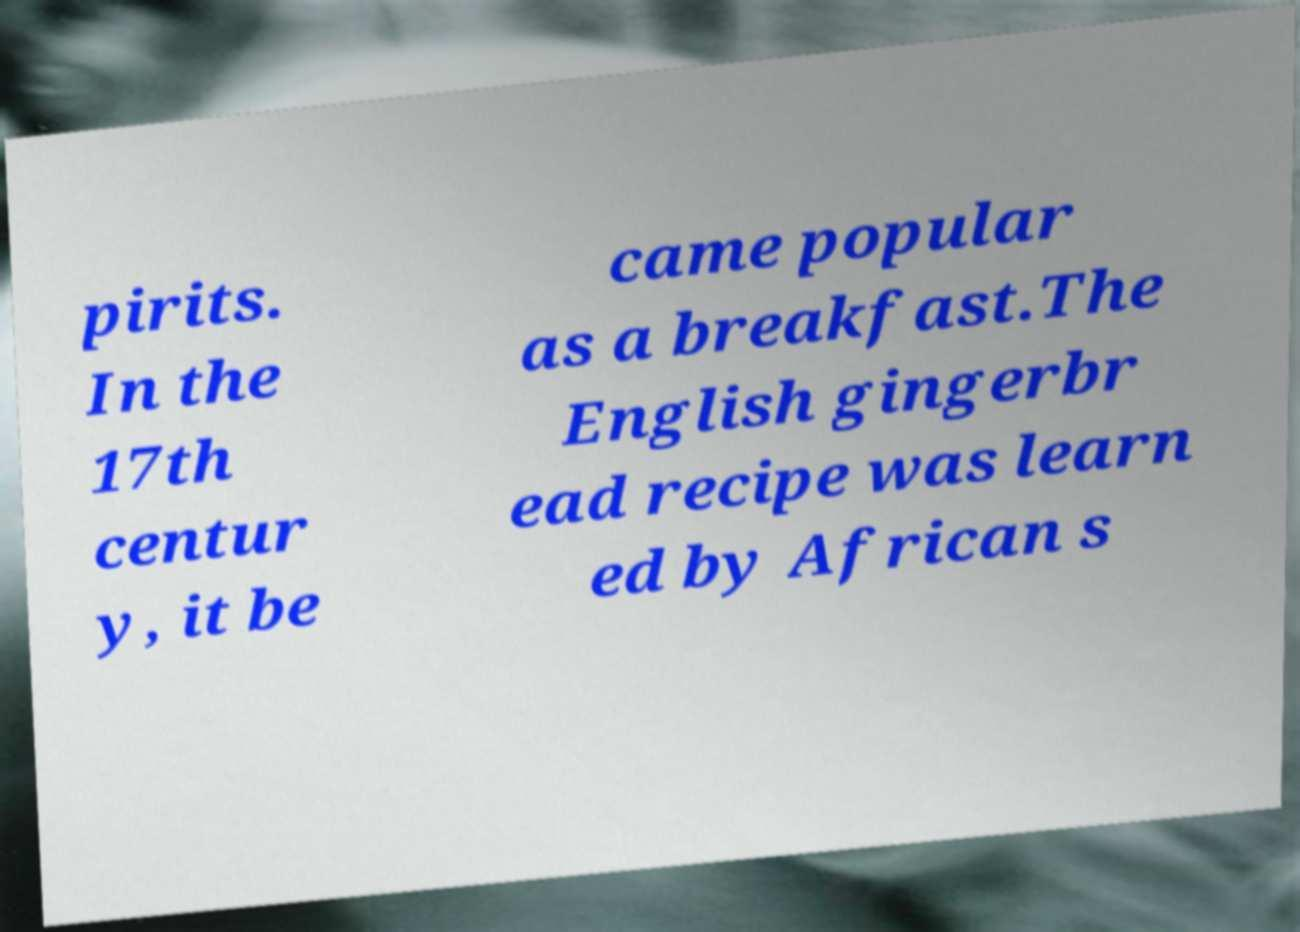Could you assist in decoding the text presented in this image and type it out clearly? pirits. In the 17th centur y, it be came popular as a breakfast.The English gingerbr ead recipe was learn ed by African s 